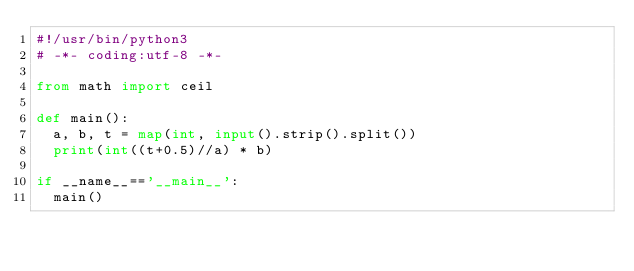Convert code to text. <code><loc_0><loc_0><loc_500><loc_500><_Python_>#!/usr/bin/python3
# -*- coding:utf-8 -*-

from math import ceil

def main():
  a, b, t = map(int, input().strip().split())
  print(int((t+0.5)//a) * b)

if __name__=='__main__':
  main()

</code> 